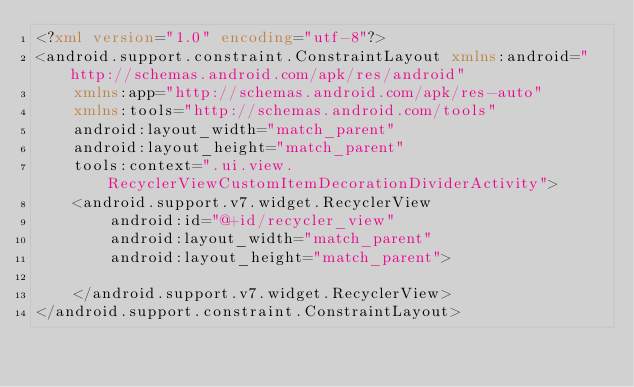Convert code to text. <code><loc_0><loc_0><loc_500><loc_500><_XML_><?xml version="1.0" encoding="utf-8"?>
<android.support.constraint.ConstraintLayout xmlns:android="http://schemas.android.com/apk/res/android"
    xmlns:app="http://schemas.android.com/apk/res-auto"
    xmlns:tools="http://schemas.android.com/tools"
    android:layout_width="match_parent"
    android:layout_height="match_parent"
    tools:context=".ui.view.RecyclerViewCustomItemDecorationDividerActivity">
    <android.support.v7.widget.RecyclerView
        android:id="@+id/recycler_view"
        android:layout_width="match_parent"
        android:layout_height="match_parent">

    </android.support.v7.widget.RecyclerView>
</android.support.constraint.ConstraintLayout></code> 